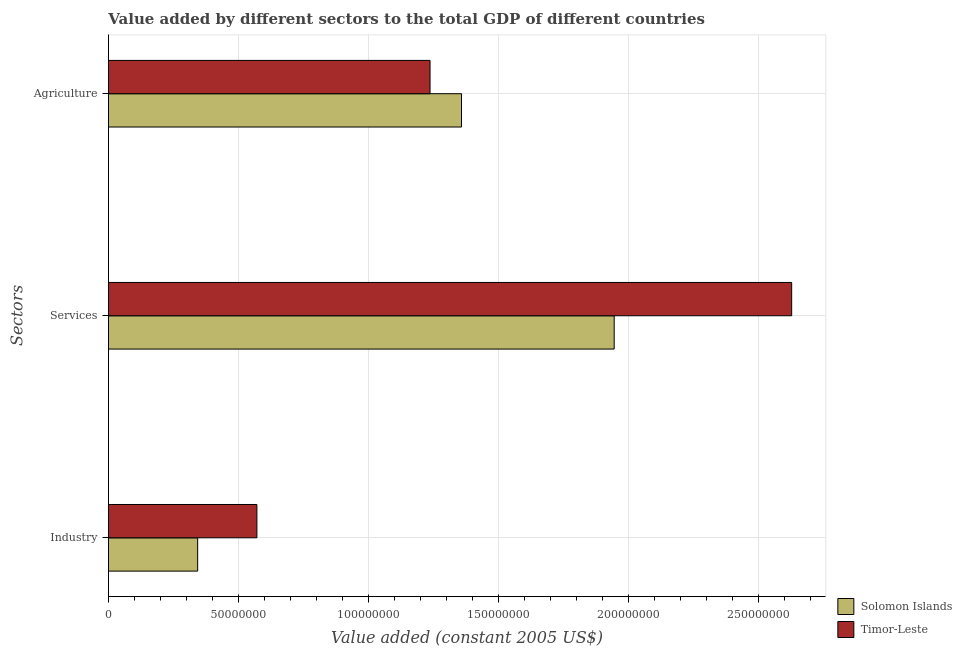How many groups of bars are there?
Offer a very short reply. 3. Are the number of bars per tick equal to the number of legend labels?
Your response must be concise. Yes. How many bars are there on the 3rd tick from the top?
Offer a terse response. 2. What is the label of the 2nd group of bars from the top?
Your answer should be very brief. Services. What is the value added by industrial sector in Solomon Islands?
Give a very brief answer. 3.43e+07. Across all countries, what is the maximum value added by agricultural sector?
Make the answer very short. 1.36e+08. Across all countries, what is the minimum value added by agricultural sector?
Provide a short and direct response. 1.24e+08. In which country was the value added by agricultural sector maximum?
Keep it short and to the point. Solomon Islands. In which country was the value added by agricultural sector minimum?
Provide a succinct answer. Timor-Leste. What is the total value added by services in the graph?
Keep it short and to the point. 4.57e+08. What is the difference between the value added by industrial sector in Solomon Islands and that in Timor-Leste?
Provide a short and direct response. -2.28e+07. What is the difference between the value added by industrial sector in Solomon Islands and the value added by services in Timor-Leste?
Keep it short and to the point. -2.28e+08. What is the average value added by industrial sector per country?
Keep it short and to the point. 4.57e+07. What is the difference between the value added by services and value added by industrial sector in Solomon Islands?
Give a very brief answer. 1.60e+08. What is the ratio of the value added by agricultural sector in Solomon Islands to that in Timor-Leste?
Provide a short and direct response. 1.1. Is the value added by services in Timor-Leste less than that in Solomon Islands?
Keep it short and to the point. No. What is the difference between the highest and the second highest value added by industrial sector?
Offer a terse response. 2.28e+07. What is the difference between the highest and the lowest value added by agricultural sector?
Offer a very short reply. 1.21e+07. In how many countries, is the value added by agricultural sector greater than the average value added by agricultural sector taken over all countries?
Your answer should be compact. 1. Is the sum of the value added by industrial sector in Solomon Islands and Timor-Leste greater than the maximum value added by services across all countries?
Keep it short and to the point. No. What does the 2nd bar from the top in Industry represents?
Provide a succinct answer. Solomon Islands. What does the 2nd bar from the bottom in Services represents?
Provide a succinct answer. Timor-Leste. Are all the bars in the graph horizontal?
Your answer should be compact. Yes. What is the difference between two consecutive major ticks on the X-axis?
Provide a short and direct response. 5.00e+07. Are the values on the major ticks of X-axis written in scientific E-notation?
Provide a short and direct response. No. Does the graph contain grids?
Make the answer very short. Yes. What is the title of the graph?
Offer a terse response. Value added by different sectors to the total GDP of different countries. Does "San Marino" appear as one of the legend labels in the graph?
Make the answer very short. No. What is the label or title of the X-axis?
Make the answer very short. Value added (constant 2005 US$). What is the label or title of the Y-axis?
Your response must be concise. Sectors. What is the Value added (constant 2005 US$) in Solomon Islands in Industry?
Ensure brevity in your answer.  3.43e+07. What is the Value added (constant 2005 US$) in Timor-Leste in Industry?
Your answer should be very brief. 5.71e+07. What is the Value added (constant 2005 US$) in Solomon Islands in Services?
Your answer should be very brief. 1.94e+08. What is the Value added (constant 2005 US$) in Timor-Leste in Services?
Your answer should be very brief. 2.63e+08. What is the Value added (constant 2005 US$) of Solomon Islands in Agriculture?
Provide a short and direct response. 1.36e+08. What is the Value added (constant 2005 US$) in Timor-Leste in Agriculture?
Provide a short and direct response. 1.24e+08. Across all Sectors, what is the maximum Value added (constant 2005 US$) in Solomon Islands?
Offer a very short reply. 1.94e+08. Across all Sectors, what is the maximum Value added (constant 2005 US$) in Timor-Leste?
Ensure brevity in your answer.  2.63e+08. Across all Sectors, what is the minimum Value added (constant 2005 US$) of Solomon Islands?
Make the answer very short. 3.43e+07. Across all Sectors, what is the minimum Value added (constant 2005 US$) of Timor-Leste?
Ensure brevity in your answer.  5.71e+07. What is the total Value added (constant 2005 US$) in Solomon Islands in the graph?
Offer a terse response. 3.64e+08. What is the total Value added (constant 2005 US$) in Timor-Leste in the graph?
Ensure brevity in your answer.  4.43e+08. What is the difference between the Value added (constant 2005 US$) in Solomon Islands in Industry and that in Services?
Make the answer very short. -1.60e+08. What is the difference between the Value added (constant 2005 US$) in Timor-Leste in Industry and that in Services?
Your response must be concise. -2.06e+08. What is the difference between the Value added (constant 2005 US$) of Solomon Islands in Industry and that in Agriculture?
Your response must be concise. -1.01e+08. What is the difference between the Value added (constant 2005 US$) in Timor-Leste in Industry and that in Agriculture?
Your response must be concise. -6.66e+07. What is the difference between the Value added (constant 2005 US$) in Solomon Islands in Services and that in Agriculture?
Your answer should be compact. 5.87e+07. What is the difference between the Value added (constant 2005 US$) of Timor-Leste in Services and that in Agriculture?
Your response must be concise. 1.39e+08. What is the difference between the Value added (constant 2005 US$) of Solomon Islands in Industry and the Value added (constant 2005 US$) of Timor-Leste in Services?
Make the answer very short. -2.28e+08. What is the difference between the Value added (constant 2005 US$) of Solomon Islands in Industry and the Value added (constant 2005 US$) of Timor-Leste in Agriculture?
Give a very brief answer. -8.93e+07. What is the difference between the Value added (constant 2005 US$) of Solomon Islands in Services and the Value added (constant 2005 US$) of Timor-Leste in Agriculture?
Your answer should be very brief. 7.08e+07. What is the average Value added (constant 2005 US$) of Solomon Islands per Sectors?
Offer a terse response. 1.21e+08. What is the average Value added (constant 2005 US$) in Timor-Leste per Sectors?
Provide a succinct answer. 1.48e+08. What is the difference between the Value added (constant 2005 US$) in Solomon Islands and Value added (constant 2005 US$) in Timor-Leste in Industry?
Your answer should be compact. -2.28e+07. What is the difference between the Value added (constant 2005 US$) of Solomon Islands and Value added (constant 2005 US$) of Timor-Leste in Services?
Offer a very short reply. -6.82e+07. What is the difference between the Value added (constant 2005 US$) of Solomon Islands and Value added (constant 2005 US$) of Timor-Leste in Agriculture?
Provide a short and direct response. 1.21e+07. What is the ratio of the Value added (constant 2005 US$) of Solomon Islands in Industry to that in Services?
Provide a short and direct response. 0.18. What is the ratio of the Value added (constant 2005 US$) in Timor-Leste in Industry to that in Services?
Your response must be concise. 0.22. What is the ratio of the Value added (constant 2005 US$) of Solomon Islands in Industry to that in Agriculture?
Ensure brevity in your answer.  0.25. What is the ratio of the Value added (constant 2005 US$) in Timor-Leste in Industry to that in Agriculture?
Your answer should be compact. 0.46. What is the ratio of the Value added (constant 2005 US$) in Solomon Islands in Services to that in Agriculture?
Provide a short and direct response. 1.43. What is the ratio of the Value added (constant 2005 US$) in Timor-Leste in Services to that in Agriculture?
Your response must be concise. 2.12. What is the difference between the highest and the second highest Value added (constant 2005 US$) in Solomon Islands?
Your answer should be very brief. 5.87e+07. What is the difference between the highest and the second highest Value added (constant 2005 US$) in Timor-Leste?
Provide a short and direct response. 1.39e+08. What is the difference between the highest and the lowest Value added (constant 2005 US$) in Solomon Islands?
Give a very brief answer. 1.60e+08. What is the difference between the highest and the lowest Value added (constant 2005 US$) in Timor-Leste?
Give a very brief answer. 2.06e+08. 